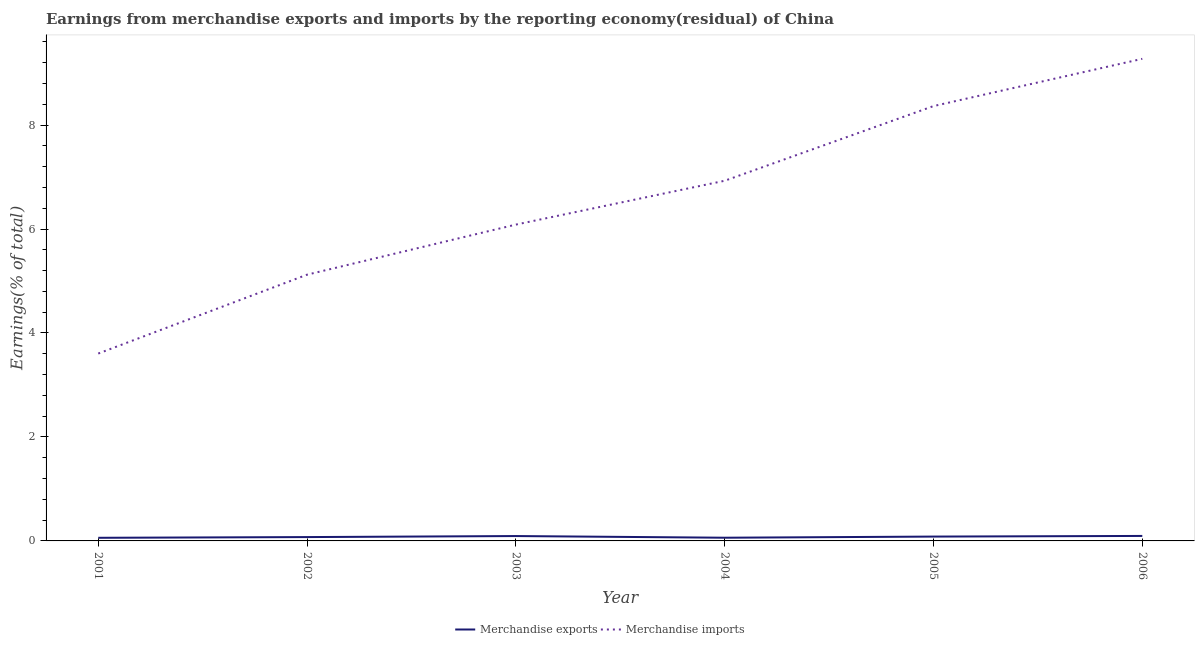Is the number of lines equal to the number of legend labels?
Ensure brevity in your answer.  Yes. What is the earnings from merchandise exports in 2001?
Give a very brief answer. 0.06. Across all years, what is the maximum earnings from merchandise imports?
Give a very brief answer. 9.27. Across all years, what is the minimum earnings from merchandise imports?
Make the answer very short. 3.6. What is the total earnings from merchandise exports in the graph?
Provide a short and direct response. 0.47. What is the difference between the earnings from merchandise imports in 2001 and that in 2006?
Make the answer very short. -5.67. What is the difference between the earnings from merchandise exports in 2003 and the earnings from merchandise imports in 2002?
Provide a succinct answer. -5.03. What is the average earnings from merchandise exports per year?
Provide a short and direct response. 0.08. In the year 2003, what is the difference between the earnings from merchandise imports and earnings from merchandise exports?
Keep it short and to the point. 5.99. In how many years, is the earnings from merchandise imports greater than 3.6 %?
Keep it short and to the point. 6. What is the ratio of the earnings from merchandise exports in 2001 to that in 2002?
Your answer should be very brief. 0.81. Is the earnings from merchandise exports in 2004 less than that in 2005?
Offer a terse response. Yes. What is the difference between the highest and the second highest earnings from merchandise exports?
Your answer should be compact. 0. What is the difference between the highest and the lowest earnings from merchandise exports?
Make the answer very short. 0.04. How many lines are there?
Make the answer very short. 2. How many years are there in the graph?
Make the answer very short. 6. Are the values on the major ticks of Y-axis written in scientific E-notation?
Keep it short and to the point. No. Does the graph contain any zero values?
Your answer should be very brief. No. Does the graph contain grids?
Make the answer very short. No. What is the title of the graph?
Keep it short and to the point. Earnings from merchandise exports and imports by the reporting economy(residual) of China. Does "Depositors" appear as one of the legend labels in the graph?
Your answer should be compact. No. What is the label or title of the Y-axis?
Offer a terse response. Earnings(% of total). What is the Earnings(% of total) of Merchandise exports in 2001?
Your response must be concise. 0.06. What is the Earnings(% of total) of Merchandise imports in 2001?
Your answer should be very brief. 3.6. What is the Earnings(% of total) in Merchandise exports in 2002?
Your answer should be compact. 0.07. What is the Earnings(% of total) in Merchandise imports in 2002?
Offer a very short reply. 5.12. What is the Earnings(% of total) in Merchandise exports in 2003?
Offer a very short reply. 0.09. What is the Earnings(% of total) in Merchandise imports in 2003?
Your answer should be compact. 6.09. What is the Earnings(% of total) of Merchandise exports in 2004?
Your response must be concise. 0.06. What is the Earnings(% of total) of Merchandise imports in 2004?
Offer a terse response. 6.93. What is the Earnings(% of total) in Merchandise exports in 2005?
Your response must be concise. 0.08. What is the Earnings(% of total) of Merchandise imports in 2005?
Your answer should be very brief. 8.37. What is the Earnings(% of total) of Merchandise exports in 2006?
Your answer should be compact. 0.1. What is the Earnings(% of total) in Merchandise imports in 2006?
Offer a terse response. 9.27. Across all years, what is the maximum Earnings(% of total) in Merchandise exports?
Offer a terse response. 0.1. Across all years, what is the maximum Earnings(% of total) in Merchandise imports?
Your answer should be compact. 9.27. Across all years, what is the minimum Earnings(% of total) in Merchandise exports?
Provide a short and direct response. 0.06. Across all years, what is the minimum Earnings(% of total) of Merchandise imports?
Your answer should be very brief. 3.6. What is the total Earnings(% of total) of Merchandise exports in the graph?
Provide a succinct answer. 0.47. What is the total Earnings(% of total) of Merchandise imports in the graph?
Provide a short and direct response. 39.38. What is the difference between the Earnings(% of total) in Merchandise exports in 2001 and that in 2002?
Give a very brief answer. -0.01. What is the difference between the Earnings(% of total) of Merchandise imports in 2001 and that in 2002?
Your response must be concise. -1.52. What is the difference between the Earnings(% of total) of Merchandise exports in 2001 and that in 2003?
Provide a succinct answer. -0.03. What is the difference between the Earnings(% of total) of Merchandise imports in 2001 and that in 2003?
Make the answer very short. -2.48. What is the difference between the Earnings(% of total) of Merchandise exports in 2001 and that in 2004?
Provide a short and direct response. -0. What is the difference between the Earnings(% of total) of Merchandise imports in 2001 and that in 2004?
Provide a succinct answer. -3.32. What is the difference between the Earnings(% of total) of Merchandise exports in 2001 and that in 2005?
Your answer should be compact. -0.02. What is the difference between the Earnings(% of total) of Merchandise imports in 2001 and that in 2005?
Provide a short and direct response. -4.76. What is the difference between the Earnings(% of total) in Merchandise exports in 2001 and that in 2006?
Your answer should be compact. -0.04. What is the difference between the Earnings(% of total) in Merchandise imports in 2001 and that in 2006?
Give a very brief answer. -5.67. What is the difference between the Earnings(% of total) of Merchandise exports in 2002 and that in 2003?
Your answer should be very brief. -0.02. What is the difference between the Earnings(% of total) of Merchandise imports in 2002 and that in 2003?
Your answer should be compact. -0.96. What is the difference between the Earnings(% of total) in Merchandise exports in 2002 and that in 2004?
Keep it short and to the point. 0.01. What is the difference between the Earnings(% of total) of Merchandise imports in 2002 and that in 2004?
Keep it short and to the point. -1.81. What is the difference between the Earnings(% of total) in Merchandise exports in 2002 and that in 2005?
Keep it short and to the point. -0.01. What is the difference between the Earnings(% of total) in Merchandise imports in 2002 and that in 2005?
Keep it short and to the point. -3.24. What is the difference between the Earnings(% of total) in Merchandise exports in 2002 and that in 2006?
Offer a very short reply. -0.02. What is the difference between the Earnings(% of total) of Merchandise imports in 2002 and that in 2006?
Your answer should be compact. -4.15. What is the difference between the Earnings(% of total) in Merchandise exports in 2003 and that in 2004?
Your answer should be very brief. 0.03. What is the difference between the Earnings(% of total) of Merchandise imports in 2003 and that in 2004?
Your response must be concise. -0.84. What is the difference between the Earnings(% of total) of Merchandise exports in 2003 and that in 2005?
Keep it short and to the point. 0.01. What is the difference between the Earnings(% of total) in Merchandise imports in 2003 and that in 2005?
Make the answer very short. -2.28. What is the difference between the Earnings(% of total) in Merchandise exports in 2003 and that in 2006?
Your answer should be very brief. -0. What is the difference between the Earnings(% of total) of Merchandise imports in 2003 and that in 2006?
Offer a terse response. -3.19. What is the difference between the Earnings(% of total) in Merchandise exports in 2004 and that in 2005?
Ensure brevity in your answer.  -0.02. What is the difference between the Earnings(% of total) of Merchandise imports in 2004 and that in 2005?
Make the answer very short. -1.44. What is the difference between the Earnings(% of total) in Merchandise exports in 2004 and that in 2006?
Your answer should be very brief. -0.03. What is the difference between the Earnings(% of total) of Merchandise imports in 2004 and that in 2006?
Offer a terse response. -2.35. What is the difference between the Earnings(% of total) in Merchandise exports in 2005 and that in 2006?
Your answer should be compact. -0.01. What is the difference between the Earnings(% of total) in Merchandise imports in 2005 and that in 2006?
Give a very brief answer. -0.91. What is the difference between the Earnings(% of total) in Merchandise exports in 2001 and the Earnings(% of total) in Merchandise imports in 2002?
Offer a very short reply. -5.06. What is the difference between the Earnings(% of total) of Merchandise exports in 2001 and the Earnings(% of total) of Merchandise imports in 2003?
Ensure brevity in your answer.  -6.03. What is the difference between the Earnings(% of total) of Merchandise exports in 2001 and the Earnings(% of total) of Merchandise imports in 2004?
Offer a very short reply. -6.87. What is the difference between the Earnings(% of total) of Merchandise exports in 2001 and the Earnings(% of total) of Merchandise imports in 2005?
Offer a terse response. -8.3. What is the difference between the Earnings(% of total) in Merchandise exports in 2001 and the Earnings(% of total) in Merchandise imports in 2006?
Keep it short and to the point. -9.21. What is the difference between the Earnings(% of total) in Merchandise exports in 2002 and the Earnings(% of total) in Merchandise imports in 2003?
Offer a terse response. -6.01. What is the difference between the Earnings(% of total) in Merchandise exports in 2002 and the Earnings(% of total) in Merchandise imports in 2004?
Offer a very short reply. -6.85. What is the difference between the Earnings(% of total) of Merchandise exports in 2002 and the Earnings(% of total) of Merchandise imports in 2005?
Offer a terse response. -8.29. What is the difference between the Earnings(% of total) in Merchandise exports in 2002 and the Earnings(% of total) in Merchandise imports in 2006?
Give a very brief answer. -9.2. What is the difference between the Earnings(% of total) of Merchandise exports in 2003 and the Earnings(% of total) of Merchandise imports in 2004?
Give a very brief answer. -6.83. What is the difference between the Earnings(% of total) in Merchandise exports in 2003 and the Earnings(% of total) in Merchandise imports in 2005?
Give a very brief answer. -8.27. What is the difference between the Earnings(% of total) in Merchandise exports in 2003 and the Earnings(% of total) in Merchandise imports in 2006?
Offer a very short reply. -9.18. What is the difference between the Earnings(% of total) in Merchandise exports in 2004 and the Earnings(% of total) in Merchandise imports in 2005?
Provide a short and direct response. -8.3. What is the difference between the Earnings(% of total) in Merchandise exports in 2004 and the Earnings(% of total) in Merchandise imports in 2006?
Ensure brevity in your answer.  -9.21. What is the difference between the Earnings(% of total) in Merchandise exports in 2005 and the Earnings(% of total) in Merchandise imports in 2006?
Provide a short and direct response. -9.19. What is the average Earnings(% of total) in Merchandise exports per year?
Offer a terse response. 0.08. What is the average Earnings(% of total) of Merchandise imports per year?
Offer a very short reply. 6.56. In the year 2001, what is the difference between the Earnings(% of total) of Merchandise exports and Earnings(% of total) of Merchandise imports?
Give a very brief answer. -3.54. In the year 2002, what is the difference between the Earnings(% of total) in Merchandise exports and Earnings(% of total) in Merchandise imports?
Your answer should be very brief. -5.05. In the year 2003, what is the difference between the Earnings(% of total) in Merchandise exports and Earnings(% of total) in Merchandise imports?
Give a very brief answer. -5.99. In the year 2004, what is the difference between the Earnings(% of total) of Merchandise exports and Earnings(% of total) of Merchandise imports?
Your answer should be compact. -6.87. In the year 2005, what is the difference between the Earnings(% of total) in Merchandise exports and Earnings(% of total) in Merchandise imports?
Provide a succinct answer. -8.28. In the year 2006, what is the difference between the Earnings(% of total) of Merchandise exports and Earnings(% of total) of Merchandise imports?
Make the answer very short. -9.18. What is the ratio of the Earnings(% of total) in Merchandise exports in 2001 to that in 2002?
Ensure brevity in your answer.  0.81. What is the ratio of the Earnings(% of total) in Merchandise imports in 2001 to that in 2002?
Make the answer very short. 0.7. What is the ratio of the Earnings(% of total) in Merchandise exports in 2001 to that in 2003?
Your answer should be very brief. 0.64. What is the ratio of the Earnings(% of total) of Merchandise imports in 2001 to that in 2003?
Provide a succinct answer. 0.59. What is the ratio of the Earnings(% of total) of Merchandise exports in 2001 to that in 2004?
Make the answer very short. 0.97. What is the ratio of the Earnings(% of total) in Merchandise imports in 2001 to that in 2004?
Provide a succinct answer. 0.52. What is the ratio of the Earnings(% of total) of Merchandise exports in 2001 to that in 2005?
Offer a terse response. 0.72. What is the ratio of the Earnings(% of total) in Merchandise imports in 2001 to that in 2005?
Your answer should be very brief. 0.43. What is the ratio of the Earnings(% of total) in Merchandise exports in 2001 to that in 2006?
Ensure brevity in your answer.  0.63. What is the ratio of the Earnings(% of total) in Merchandise imports in 2001 to that in 2006?
Ensure brevity in your answer.  0.39. What is the ratio of the Earnings(% of total) of Merchandise exports in 2002 to that in 2003?
Your answer should be compact. 0.79. What is the ratio of the Earnings(% of total) of Merchandise imports in 2002 to that in 2003?
Keep it short and to the point. 0.84. What is the ratio of the Earnings(% of total) in Merchandise exports in 2002 to that in 2004?
Ensure brevity in your answer.  1.2. What is the ratio of the Earnings(% of total) in Merchandise imports in 2002 to that in 2004?
Your answer should be compact. 0.74. What is the ratio of the Earnings(% of total) in Merchandise exports in 2002 to that in 2005?
Ensure brevity in your answer.  0.88. What is the ratio of the Earnings(% of total) in Merchandise imports in 2002 to that in 2005?
Provide a succinct answer. 0.61. What is the ratio of the Earnings(% of total) of Merchandise exports in 2002 to that in 2006?
Give a very brief answer. 0.77. What is the ratio of the Earnings(% of total) in Merchandise imports in 2002 to that in 2006?
Your answer should be very brief. 0.55. What is the ratio of the Earnings(% of total) in Merchandise exports in 2003 to that in 2004?
Your answer should be very brief. 1.52. What is the ratio of the Earnings(% of total) of Merchandise imports in 2003 to that in 2004?
Ensure brevity in your answer.  0.88. What is the ratio of the Earnings(% of total) in Merchandise exports in 2003 to that in 2005?
Give a very brief answer. 1.12. What is the ratio of the Earnings(% of total) of Merchandise imports in 2003 to that in 2005?
Provide a succinct answer. 0.73. What is the ratio of the Earnings(% of total) in Merchandise exports in 2003 to that in 2006?
Offer a terse response. 0.98. What is the ratio of the Earnings(% of total) in Merchandise imports in 2003 to that in 2006?
Your answer should be compact. 0.66. What is the ratio of the Earnings(% of total) in Merchandise exports in 2004 to that in 2005?
Offer a terse response. 0.74. What is the ratio of the Earnings(% of total) of Merchandise imports in 2004 to that in 2005?
Your answer should be very brief. 0.83. What is the ratio of the Earnings(% of total) of Merchandise exports in 2004 to that in 2006?
Offer a very short reply. 0.64. What is the ratio of the Earnings(% of total) in Merchandise imports in 2004 to that in 2006?
Provide a short and direct response. 0.75. What is the ratio of the Earnings(% of total) of Merchandise exports in 2005 to that in 2006?
Ensure brevity in your answer.  0.87. What is the ratio of the Earnings(% of total) in Merchandise imports in 2005 to that in 2006?
Provide a succinct answer. 0.9. What is the difference between the highest and the second highest Earnings(% of total) of Merchandise exports?
Your answer should be compact. 0. What is the difference between the highest and the second highest Earnings(% of total) in Merchandise imports?
Your response must be concise. 0.91. What is the difference between the highest and the lowest Earnings(% of total) in Merchandise exports?
Make the answer very short. 0.04. What is the difference between the highest and the lowest Earnings(% of total) of Merchandise imports?
Make the answer very short. 5.67. 